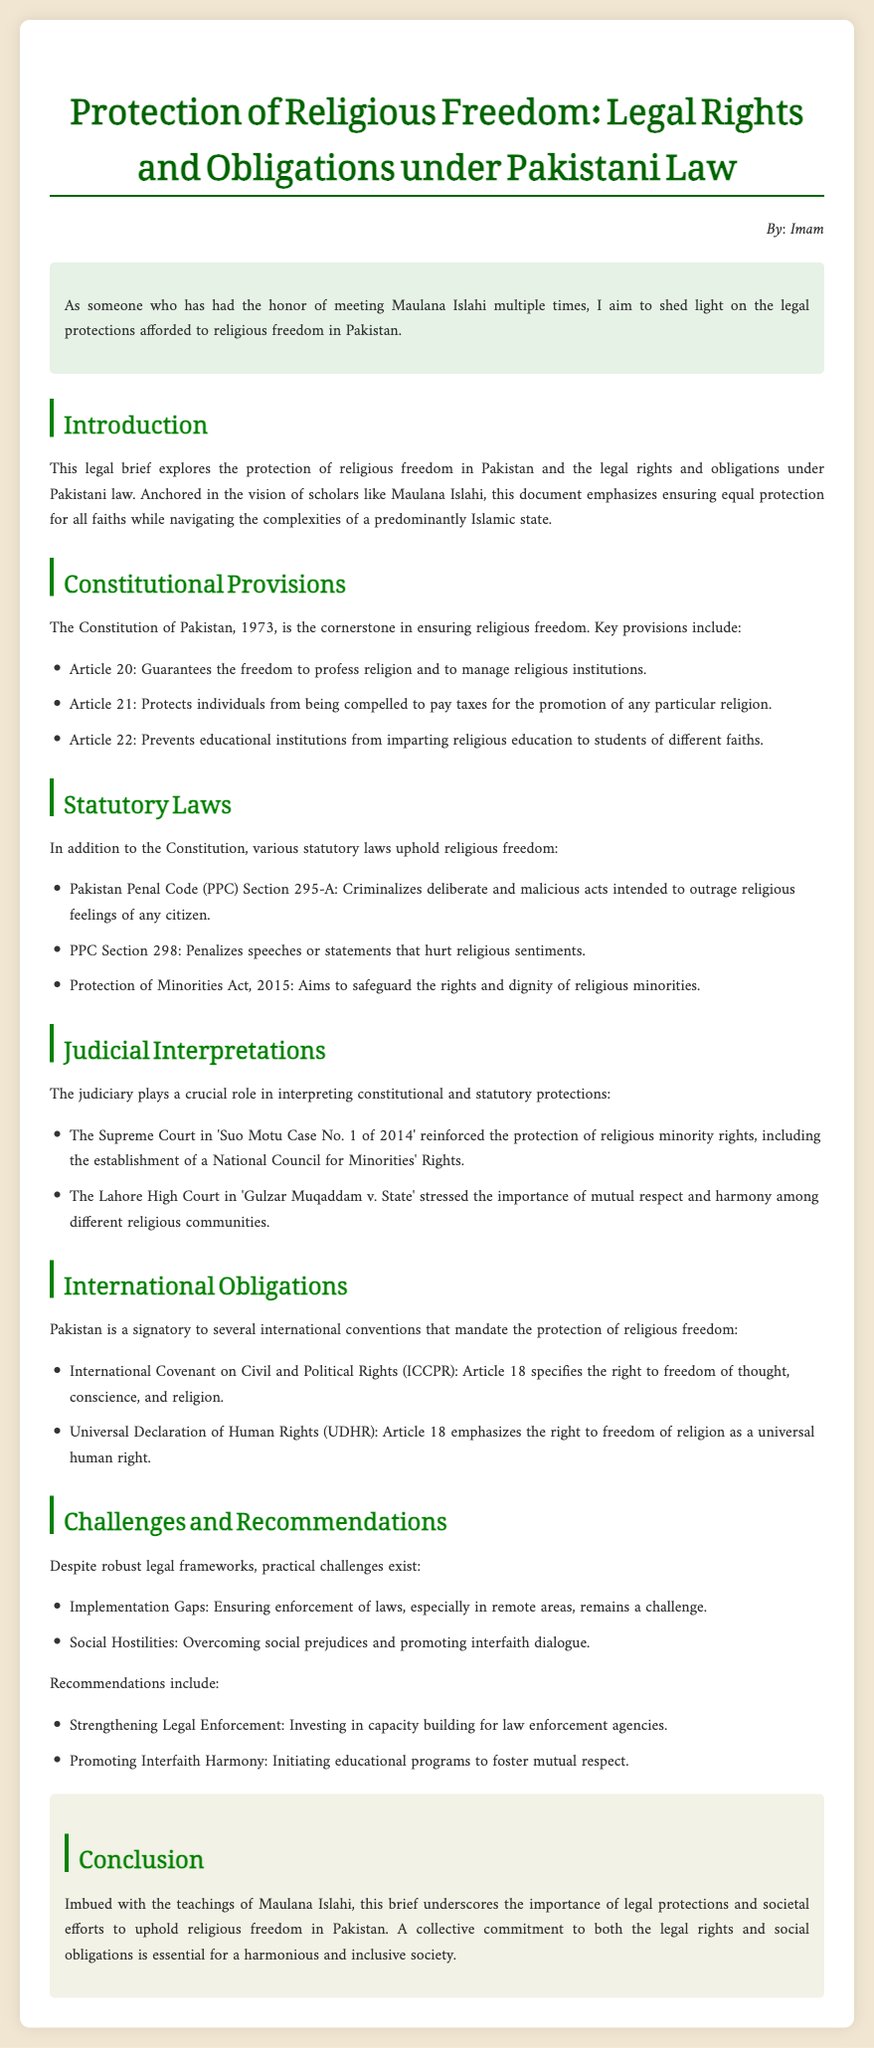What is the title of the legal brief? The title is the main subject of the document, which highlights the focus on religious freedom.
Answer: Protection of Religious Freedom: Legal Rights and Obligations under Pakistani Law Who authored the document? The author is indicated at the beginning of the document, providing a personal touch.
Answer: Imam Which article guarantees freedom to profess religion? Article 20 specifically mentions the guarantee for individuals to profess their religion freely.
Answer: Article 20 What law criminalizes acts intended to outrage religious feelings? The document includes specific sections of the Pakistan Penal Code pertinent to religious sentiments.
Answer: PPC Section 295-A What is the judicial case that reinforced the protection of religious minority rights? This refers to a Supreme Court case that supports minority rights in Pakistan's legal framework.
Answer: Suo Motu Case No. 1 of 2014 What international covenant is mentioned regarding religious freedom? The document references international agreements that Pakistan has committed to concerning civil and political rights.
Answer: International Covenant on Civil and Political Rights (ICCPR) What challenge is noted regarding the implementation of laws? The challenges discussed describe obstacles faced despite existing legal protections in place.
Answer: Implementation Gaps What recommendation is made for promoting interfaith harmony? The brief outlines specific recommendations aimed at improving respect and understanding among different faiths.
Answer: Initiating educational programs to foster mutual respect 